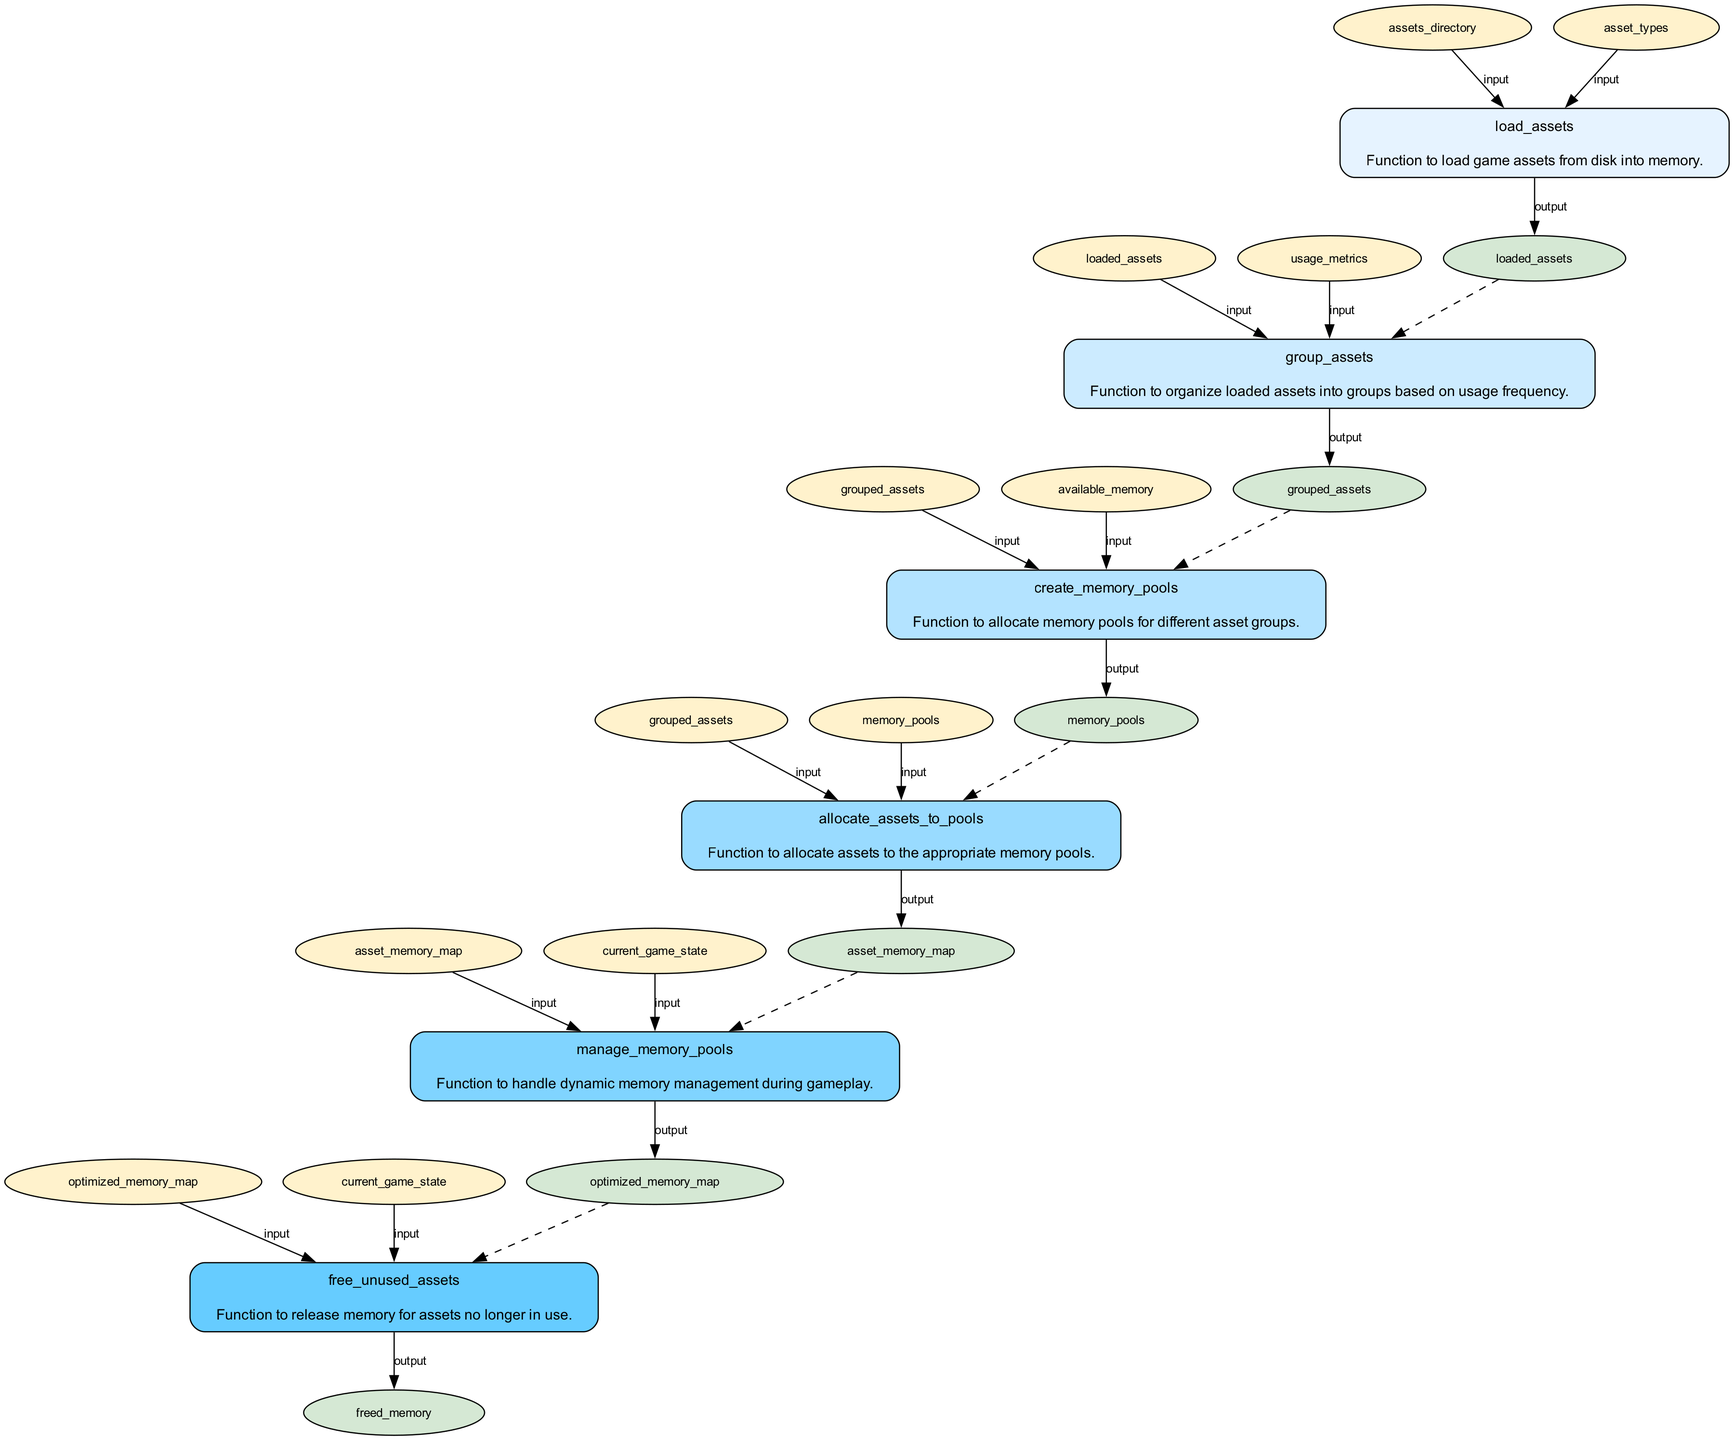What is the first function in the flowchart? The flowchart begins with the function labeled "load_assets," which is responsible for loading game assets from disk into memory.
Answer: load_assets How many functions are represented in the diagram? The diagram includes a total of six functions that deal with various aspects of memory management for game assets.
Answer: six What is the output of the 'manage_memory_pools' function? The output of the ‘manage_memory_pools’ function is labeled as "optimized_memory_map." This indicates the resulting memory configuration after management.
Answer: optimized_memory_map Which function receives 'grouped_assets' as input? The 'allocate_assets_to_pools' function is the one that receives 'grouped_assets' as input, signifying it utilizes organized asset data for allocation.
Answer: allocate_assets_to_pools What is the relationship between 'free_unused_assets' and 'optimized_memory_map'? The 'free_unused_assets' function utilizes 'optimized_memory_map' as an input to determine which assets are no longer in use and can be freed to reclaim memory.
Answer: input How many outputs does the 'create_memory_pools' function have? The 'create_memory_pools' function has only one output, which is labeled as "memory_pools," representing the allocated memory segments for the asset groups.
Answer: one Which function follows 'group_assets' in the flowchart? The function that follows 'group_assets' is 'create_memory_pools,' which comes directly after the grouping of assets in the sequence of operations.
Answer: create_memory_pools What type of edges connect the inputs and outputs to the functions in the diagram? The edges connecting the inputs to functions are indicated as 'input' edges, while those that lead from functions to outputs are labeled as 'output' edges.
Answer: input and output Which function is connected to 'freed_memory'? The 'free_unused_assets' function is connected to 'freed_memory', indicating it produces this output as part of its operation to reclaim memory.
Answer: free_unused_assets 